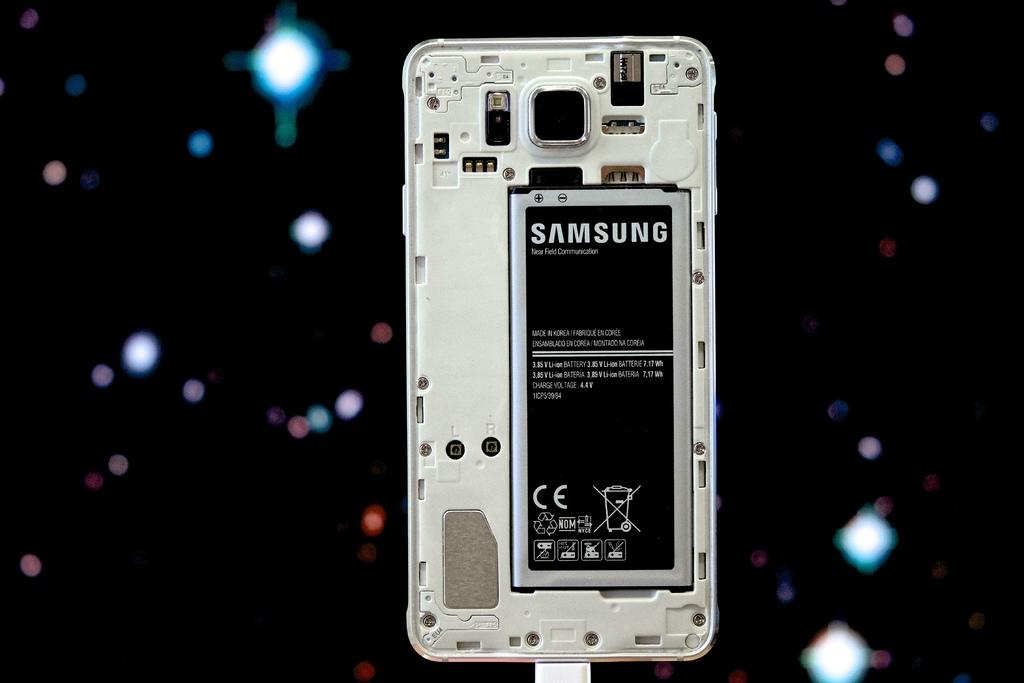<image>
Render a clear and concise summary of the photo. A Samsung battery in a mobile phone with the phone's back cover removed. 